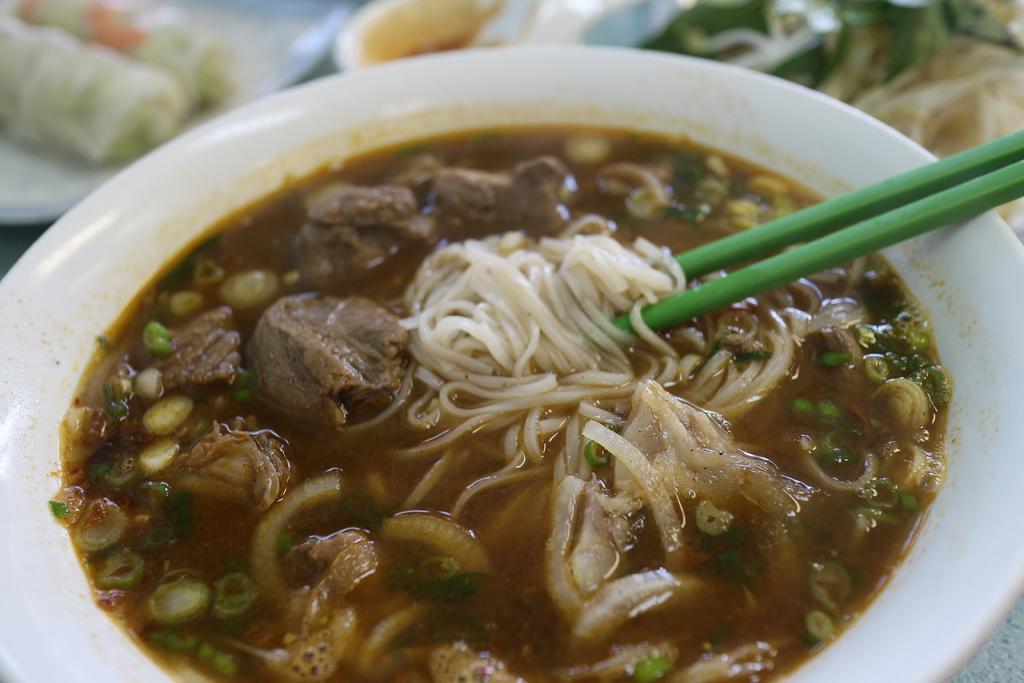Can you describe this image briefly? In this image, we can see a bowl with some liquid content and noodles. On the right side of the bowl, we can see two chopsticks. In the background, we can see some plates and bowl with food items. 